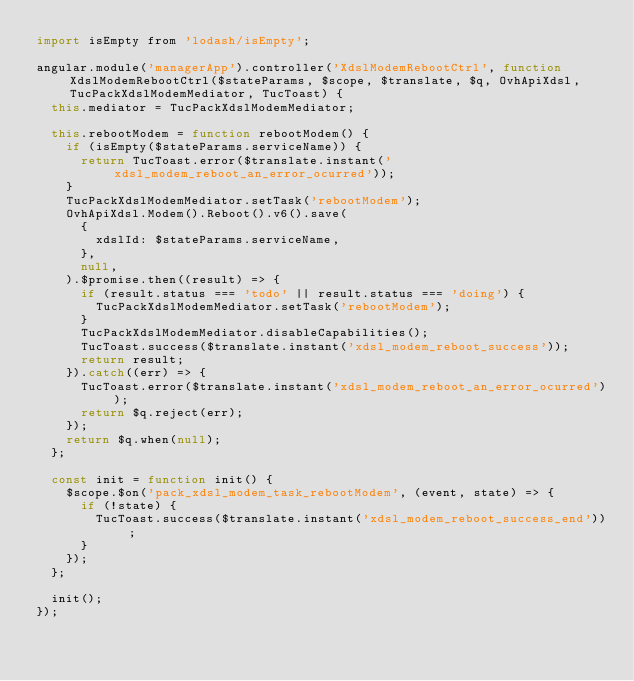<code> <loc_0><loc_0><loc_500><loc_500><_JavaScript_>import isEmpty from 'lodash/isEmpty';

angular.module('managerApp').controller('XdslModemRebootCtrl', function XdslModemRebootCtrl($stateParams, $scope, $translate, $q, OvhApiXdsl, TucPackXdslModemMediator, TucToast) {
  this.mediator = TucPackXdslModemMediator;

  this.rebootModem = function rebootModem() {
    if (isEmpty($stateParams.serviceName)) {
      return TucToast.error($translate.instant('xdsl_modem_reboot_an_error_ocurred'));
    }
    TucPackXdslModemMediator.setTask('rebootModem');
    OvhApiXdsl.Modem().Reboot().v6().save(
      {
        xdslId: $stateParams.serviceName,
      },
      null,
    ).$promise.then((result) => {
      if (result.status === 'todo' || result.status === 'doing') {
        TucPackXdslModemMediator.setTask('rebootModem');
      }
      TucPackXdslModemMediator.disableCapabilities();
      TucToast.success($translate.instant('xdsl_modem_reboot_success'));
      return result;
    }).catch((err) => {
      TucToast.error($translate.instant('xdsl_modem_reboot_an_error_ocurred'));
      return $q.reject(err);
    });
    return $q.when(null);
  };

  const init = function init() {
    $scope.$on('pack_xdsl_modem_task_rebootModem', (event, state) => {
      if (!state) {
        TucToast.success($translate.instant('xdsl_modem_reboot_success_end'));
      }
    });
  };

  init();
});
</code> 